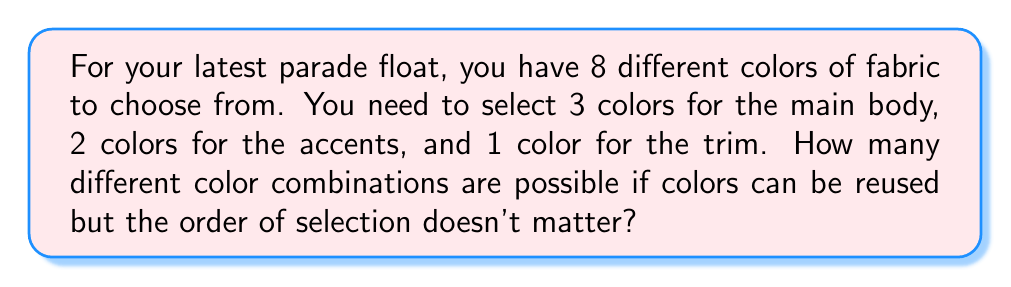Can you solve this math problem? Let's break this down step-by-step:

1) For the main body, we're choosing 3 colors out of 8, where order doesn't matter and repetition is allowed. This is a combination with repetition, denoted as:

   $$\binom{n+r-1}{r} = \binom{8+3-1}{3} = \binom{10}{3}$$

   Where $n = 8$ (number of colors) and $r = 3$ (colors chosen for main body).

2) Calculate $\binom{10}{3}$:
   $$\binom{10}{3} = \frac{10!}{3!(10-3)!} = \frac{10!}{3!7!} = 120$$

3) For the accents, we're choosing 2 colors out of 8, again with repetition allowed:

   $$\binom{8+2-1}{2} = \binom{9}{2} = \frac{9!}{2!7!} = 36$$

4) For the trim, we're simply choosing 1 color out of 8:

   $$\binom{8}{1} = 8$$

5) By the multiplication principle, the total number of possible combinations is:

   $$120 \times 36 \times 8 = 34,560$$

Thus, there are 34,560 different possible color combinations for the float.
Answer: 34,560 